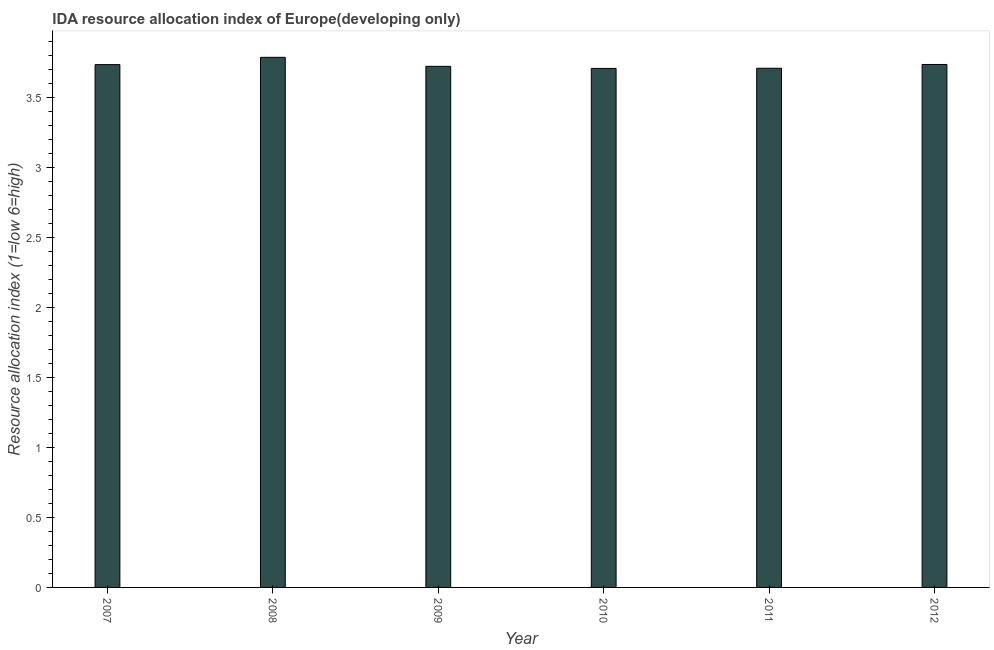What is the title of the graph?
Your answer should be compact. IDA resource allocation index of Europe(developing only). What is the label or title of the Y-axis?
Provide a succinct answer. Resource allocation index (1=low 6=high). What is the ida resource allocation index in 2007?
Your answer should be very brief. 3.74. Across all years, what is the maximum ida resource allocation index?
Provide a short and direct response. 3.79. Across all years, what is the minimum ida resource allocation index?
Provide a succinct answer. 3.71. In which year was the ida resource allocation index minimum?
Provide a short and direct response. 2010. What is the sum of the ida resource allocation index?
Provide a succinct answer. 22.4. What is the difference between the ida resource allocation index in 2007 and 2012?
Your answer should be compact. -0. What is the average ida resource allocation index per year?
Offer a very short reply. 3.73. What is the median ida resource allocation index?
Offer a very short reply. 3.73. In how many years, is the ida resource allocation index greater than 3.7 ?
Your response must be concise. 6. Do a majority of the years between 2008 and 2012 (inclusive) have ida resource allocation index greater than 2.1 ?
Provide a succinct answer. Yes. What is the ratio of the ida resource allocation index in 2007 to that in 2012?
Provide a short and direct response. 1. Is the ida resource allocation index in 2007 less than that in 2012?
Provide a short and direct response. Yes. Is the difference between the ida resource allocation index in 2008 and 2010 greater than the difference between any two years?
Your response must be concise. Yes. What is the difference between the highest and the second highest ida resource allocation index?
Provide a short and direct response. 0.05. Is the sum of the ida resource allocation index in 2007 and 2010 greater than the maximum ida resource allocation index across all years?
Give a very brief answer. Yes. What is the difference between the highest and the lowest ida resource allocation index?
Ensure brevity in your answer.  0.08. In how many years, is the ida resource allocation index greater than the average ida resource allocation index taken over all years?
Make the answer very short. 3. How many bars are there?
Give a very brief answer. 6. What is the Resource allocation index (1=low 6=high) of 2007?
Keep it short and to the point. 3.74. What is the Resource allocation index (1=low 6=high) in 2008?
Your answer should be very brief. 3.79. What is the Resource allocation index (1=low 6=high) in 2009?
Ensure brevity in your answer.  3.72. What is the Resource allocation index (1=low 6=high) of 2010?
Your answer should be very brief. 3.71. What is the Resource allocation index (1=low 6=high) of 2011?
Offer a terse response. 3.71. What is the Resource allocation index (1=low 6=high) in 2012?
Provide a short and direct response. 3.74. What is the difference between the Resource allocation index (1=low 6=high) in 2007 and 2008?
Keep it short and to the point. -0.05. What is the difference between the Resource allocation index (1=low 6=high) in 2007 and 2009?
Provide a short and direct response. 0.01. What is the difference between the Resource allocation index (1=low 6=high) in 2007 and 2010?
Give a very brief answer. 0.03. What is the difference between the Resource allocation index (1=low 6=high) in 2007 and 2011?
Your answer should be compact. 0.03. What is the difference between the Resource allocation index (1=low 6=high) in 2007 and 2012?
Your answer should be very brief. -0. What is the difference between the Resource allocation index (1=low 6=high) in 2008 and 2009?
Offer a terse response. 0.06. What is the difference between the Resource allocation index (1=low 6=high) in 2008 and 2010?
Your answer should be compact. 0.08. What is the difference between the Resource allocation index (1=low 6=high) in 2008 and 2011?
Provide a short and direct response. 0.08. What is the difference between the Resource allocation index (1=low 6=high) in 2008 and 2012?
Provide a short and direct response. 0.05. What is the difference between the Resource allocation index (1=low 6=high) in 2009 and 2010?
Your answer should be compact. 0.01. What is the difference between the Resource allocation index (1=low 6=high) in 2009 and 2011?
Offer a very short reply. 0.01. What is the difference between the Resource allocation index (1=low 6=high) in 2009 and 2012?
Your response must be concise. -0.01. What is the difference between the Resource allocation index (1=low 6=high) in 2010 and 2011?
Offer a very short reply. -0. What is the difference between the Resource allocation index (1=low 6=high) in 2010 and 2012?
Your answer should be very brief. -0.03. What is the difference between the Resource allocation index (1=low 6=high) in 2011 and 2012?
Provide a succinct answer. -0.03. What is the ratio of the Resource allocation index (1=low 6=high) in 2007 to that in 2008?
Provide a succinct answer. 0.99. What is the ratio of the Resource allocation index (1=low 6=high) in 2007 to that in 2009?
Your answer should be compact. 1. What is the ratio of the Resource allocation index (1=low 6=high) in 2007 to that in 2011?
Your answer should be very brief. 1.01. What is the ratio of the Resource allocation index (1=low 6=high) in 2007 to that in 2012?
Ensure brevity in your answer.  1. What is the ratio of the Resource allocation index (1=low 6=high) in 2008 to that in 2012?
Ensure brevity in your answer.  1.01. What is the ratio of the Resource allocation index (1=low 6=high) in 2009 to that in 2010?
Give a very brief answer. 1. What is the ratio of the Resource allocation index (1=low 6=high) in 2009 to that in 2012?
Offer a very short reply. 1. What is the ratio of the Resource allocation index (1=low 6=high) in 2010 to that in 2011?
Your answer should be compact. 1. What is the ratio of the Resource allocation index (1=low 6=high) in 2010 to that in 2012?
Your answer should be very brief. 0.99. What is the ratio of the Resource allocation index (1=low 6=high) in 2011 to that in 2012?
Offer a very short reply. 0.99. 